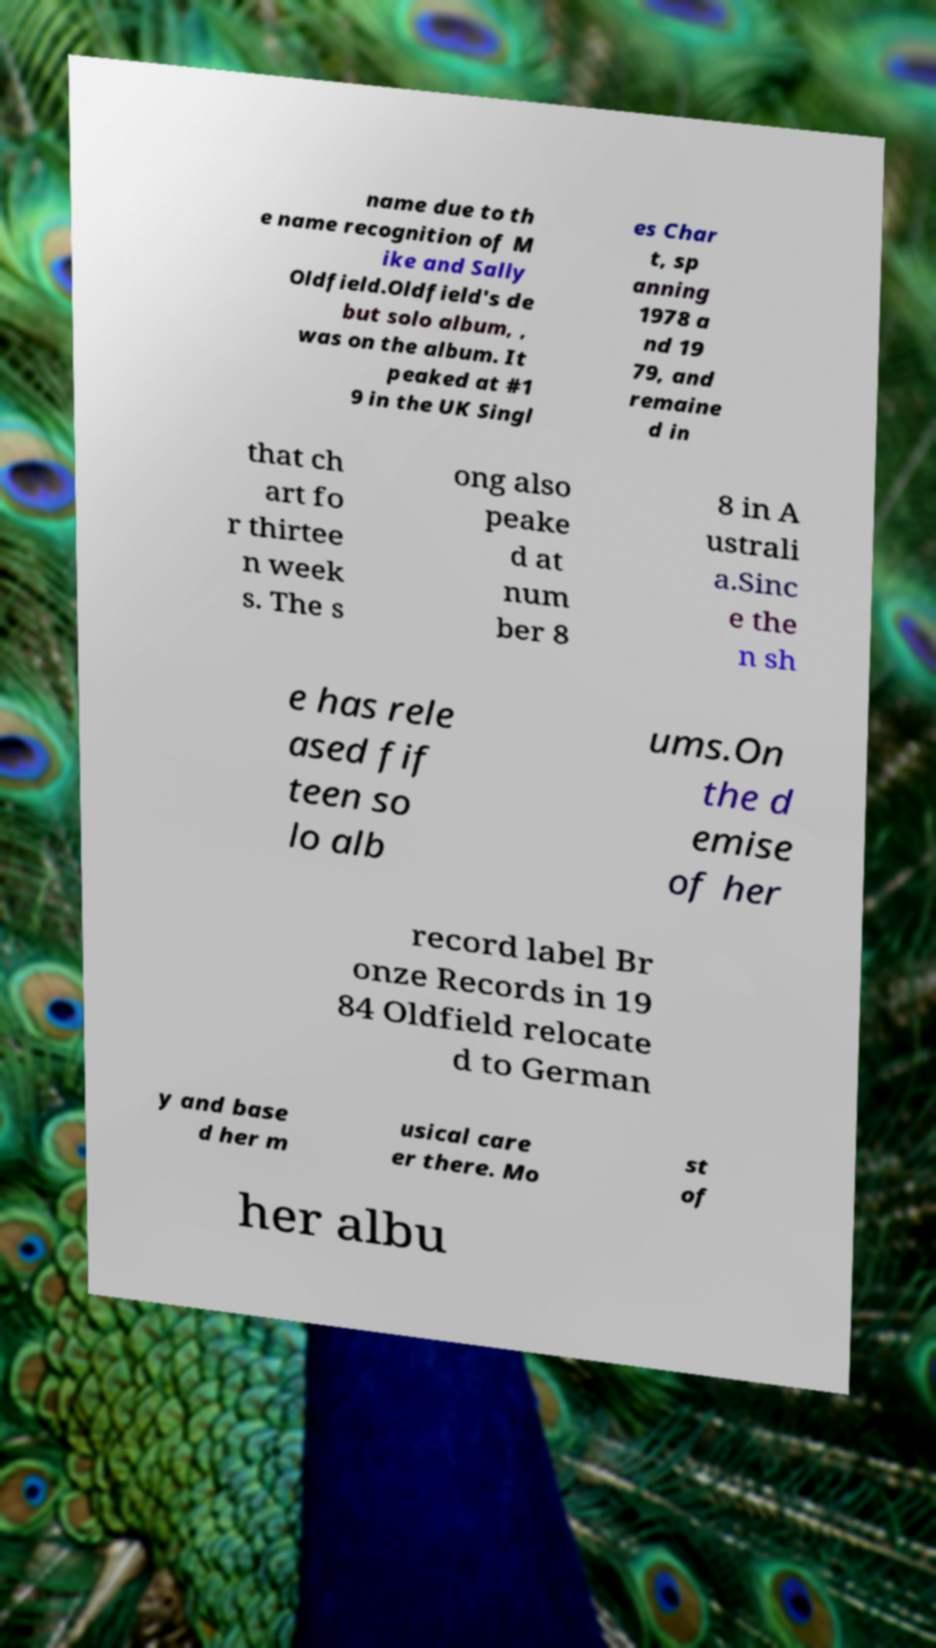Please read and relay the text visible in this image. What does it say? name due to th e name recognition of M ike and Sally Oldfield.Oldfield's de but solo album, , was on the album. It peaked at #1 9 in the UK Singl es Char t, sp anning 1978 a nd 19 79, and remaine d in that ch art fo r thirtee n week s. The s ong also peake d at num ber 8 8 in A ustrali a.Sinc e the n sh e has rele ased fif teen so lo alb ums.On the d emise of her record label Br onze Records in 19 84 Oldfield relocate d to German y and base d her m usical care er there. Mo st of her albu 